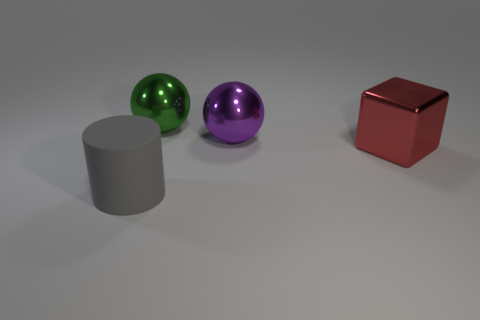Is there a metal ball right of the big object in front of the red object?
Give a very brief answer. Yes. Do the matte cylinder and the large block have the same color?
Keep it short and to the point. No. What number of other things are the same shape as the big green metal object?
Offer a very short reply. 1. Is the number of large metallic things behind the large green thing greater than the number of gray matte things on the left side of the gray object?
Your response must be concise. No. Does the object that is in front of the big red thing have the same size as the metal sphere that is on the right side of the green shiny sphere?
Provide a succinct answer. Yes. What shape is the gray thing?
Your answer should be very brief. Cylinder. The large sphere that is the same material as the green thing is what color?
Offer a very short reply. Purple. Is the big red object made of the same material as the large ball that is in front of the big green metallic sphere?
Provide a short and direct response. Yes. What color is the rubber thing?
Offer a terse response. Gray. The green sphere that is the same material as the red thing is what size?
Your answer should be compact. Large. 